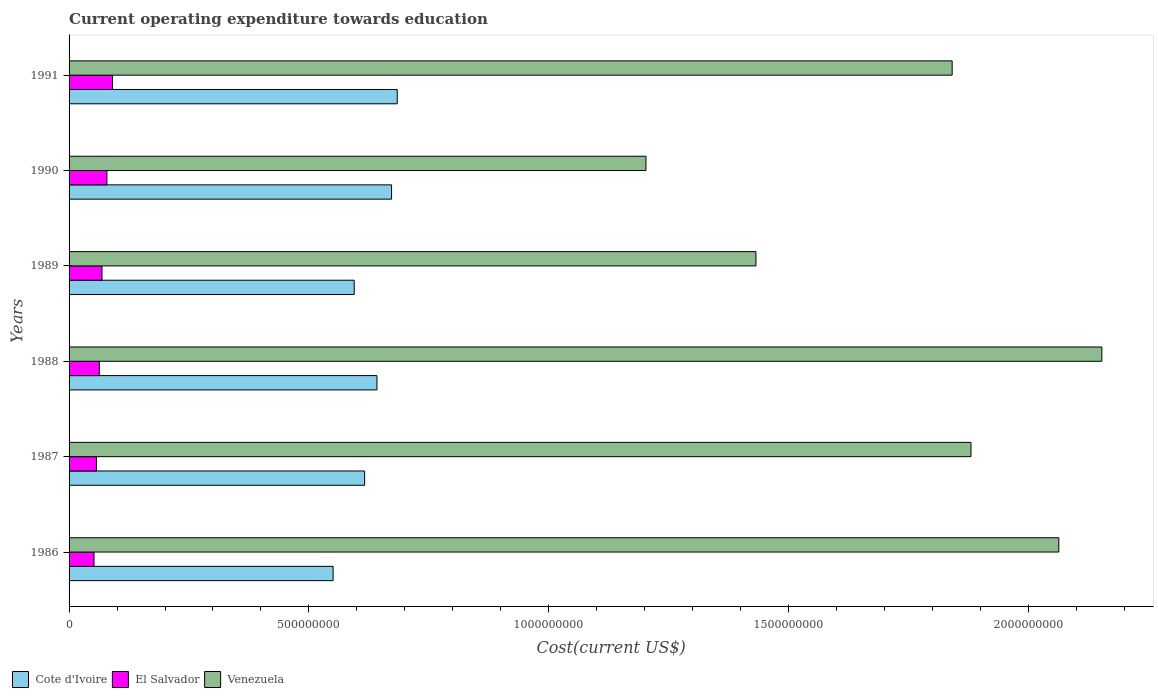Are the number of bars on each tick of the Y-axis equal?
Provide a succinct answer. Yes. What is the expenditure towards education in Venezuela in 1989?
Offer a terse response. 1.43e+09. Across all years, what is the maximum expenditure towards education in Venezuela?
Your answer should be very brief. 2.15e+09. Across all years, what is the minimum expenditure towards education in Venezuela?
Your answer should be very brief. 1.20e+09. In which year was the expenditure towards education in Venezuela minimum?
Offer a terse response. 1990. What is the total expenditure towards education in Venezuela in the graph?
Ensure brevity in your answer.  1.06e+1. What is the difference between the expenditure towards education in Venezuela in 1987 and that in 1988?
Your answer should be compact. -2.73e+08. What is the difference between the expenditure towards education in Cote d'Ivoire in 1988 and the expenditure towards education in El Salvador in 1989?
Your answer should be compact. 5.73e+08. What is the average expenditure towards education in Cote d'Ivoire per year?
Provide a short and direct response. 6.27e+08. In the year 1989, what is the difference between the expenditure towards education in Cote d'Ivoire and expenditure towards education in Venezuela?
Make the answer very short. -8.37e+08. What is the ratio of the expenditure towards education in El Salvador in 1990 to that in 1991?
Your answer should be compact. 0.87. Is the difference between the expenditure towards education in Cote d'Ivoire in 1986 and 1991 greater than the difference between the expenditure towards education in Venezuela in 1986 and 1991?
Your response must be concise. No. What is the difference between the highest and the second highest expenditure towards education in Cote d'Ivoire?
Offer a very short reply. 1.18e+07. What is the difference between the highest and the lowest expenditure towards education in Cote d'Ivoire?
Keep it short and to the point. 1.34e+08. Is the sum of the expenditure towards education in El Salvador in 1988 and 1990 greater than the maximum expenditure towards education in Cote d'Ivoire across all years?
Your response must be concise. No. What does the 1st bar from the top in 1987 represents?
Provide a short and direct response. Venezuela. What does the 2nd bar from the bottom in 1991 represents?
Your answer should be compact. El Salvador. What is the difference between two consecutive major ticks on the X-axis?
Your response must be concise. 5.00e+08. What is the title of the graph?
Provide a succinct answer. Current operating expenditure towards education. What is the label or title of the X-axis?
Make the answer very short. Cost(current US$). What is the Cost(current US$) of Cote d'Ivoire in 1986?
Make the answer very short. 5.50e+08. What is the Cost(current US$) in El Salvador in 1986?
Give a very brief answer. 5.20e+07. What is the Cost(current US$) in Venezuela in 1986?
Your response must be concise. 2.06e+09. What is the Cost(current US$) in Cote d'Ivoire in 1987?
Offer a terse response. 6.16e+08. What is the Cost(current US$) of El Salvador in 1987?
Keep it short and to the point. 5.70e+07. What is the Cost(current US$) in Venezuela in 1987?
Keep it short and to the point. 1.88e+09. What is the Cost(current US$) of Cote d'Ivoire in 1988?
Offer a very short reply. 6.42e+08. What is the Cost(current US$) of El Salvador in 1988?
Your answer should be compact. 6.31e+07. What is the Cost(current US$) of Venezuela in 1988?
Give a very brief answer. 2.15e+09. What is the Cost(current US$) of Cote d'Ivoire in 1989?
Your answer should be compact. 5.94e+08. What is the Cost(current US$) of El Salvador in 1989?
Your answer should be very brief. 6.86e+07. What is the Cost(current US$) in Venezuela in 1989?
Offer a very short reply. 1.43e+09. What is the Cost(current US$) of Cote d'Ivoire in 1990?
Your response must be concise. 6.72e+08. What is the Cost(current US$) of El Salvador in 1990?
Your answer should be compact. 7.89e+07. What is the Cost(current US$) of Venezuela in 1990?
Give a very brief answer. 1.20e+09. What is the Cost(current US$) in Cote d'Ivoire in 1991?
Ensure brevity in your answer.  6.84e+08. What is the Cost(current US$) of El Salvador in 1991?
Your response must be concise. 9.04e+07. What is the Cost(current US$) of Venezuela in 1991?
Your answer should be very brief. 1.84e+09. Across all years, what is the maximum Cost(current US$) in Cote d'Ivoire?
Make the answer very short. 6.84e+08. Across all years, what is the maximum Cost(current US$) of El Salvador?
Provide a succinct answer. 9.04e+07. Across all years, what is the maximum Cost(current US$) of Venezuela?
Give a very brief answer. 2.15e+09. Across all years, what is the minimum Cost(current US$) in Cote d'Ivoire?
Your answer should be compact. 5.50e+08. Across all years, what is the minimum Cost(current US$) of El Salvador?
Your answer should be very brief. 5.20e+07. Across all years, what is the minimum Cost(current US$) of Venezuela?
Your answer should be compact. 1.20e+09. What is the total Cost(current US$) of Cote d'Ivoire in the graph?
Offer a terse response. 3.76e+09. What is the total Cost(current US$) of El Salvador in the graph?
Keep it short and to the point. 4.10e+08. What is the total Cost(current US$) of Venezuela in the graph?
Offer a terse response. 1.06e+1. What is the difference between the Cost(current US$) of Cote d'Ivoire in 1986 and that in 1987?
Give a very brief answer. -6.57e+07. What is the difference between the Cost(current US$) in El Salvador in 1986 and that in 1987?
Give a very brief answer. -5.03e+06. What is the difference between the Cost(current US$) in Venezuela in 1986 and that in 1987?
Offer a terse response. 1.83e+08. What is the difference between the Cost(current US$) in Cote d'Ivoire in 1986 and that in 1988?
Your answer should be very brief. -9.14e+07. What is the difference between the Cost(current US$) in El Salvador in 1986 and that in 1988?
Your answer should be very brief. -1.11e+07. What is the difference between the Cost(current US$) of Venezuela in 1986 and that in 1988?
Offer a very short reply. -8.97e+07. What is the difference between the Cost(current US$) in Cote d'Ivoire in 1986 and that in 1989?
Offer a very short reply. -4.40e+07. What is the difference between the Cost(current US$) in El Salvador in 1986 and that in 1989?
Your answer should be very brief. -1.67e+07. What is the difference between the Cost(current US$) in Venezuela in 1986 and that in 1989?
Offer a terse response. 6.31e+08. What is the difference between the Cost(current US$) in Cote d'Ivoire in 1986 and that in 1990?
Provide a succinct answer. -1.22e+08. What is the difference between the Cost(current US$) of El Salvador in 1986 and that in 1990?
Provide a short and direct response. -2.69e+07. What is the difference between the Cost(current US$) of Venezuela in 1986 and that in 1990?
Provide a short and direct response. 8.61e+08. What is the difference between the Cost(current US$) of Cote d'Ivoire in 1986 and that in 1991?
Provide a succinct answer. -1.34e+08. What is the difference between the Cost(current US$) in El Salvador in 1986 and that in 1991?
Offer a very short reply. -3.85e+07. What is the difference between the Cost(current US$) in Venezuela in 1986 and that in 1991?
Your answer should be very brief. 2.22e+08. What is the difference between the Cost(current US$) of Cote d'Ivoire in 1987 and that in 1988?
Make the answer very short. -2.57e+07. What is the difference between the Cost(current US$) in El Salvador in 1987 and that in 1988?
Your answer should be very brief. -6.09e+06. What is the difference between the Cost(current US$) of Venezuela in 1987 and that in 1988?
Make the answer very short. -2.73e+08. What is the difference between the Cost(current US$) in Cote d'Ivoire in 1987 and that in 1989?
Ensure brevity in your answer.  2.17e+07. What is the difference between the Cost(current US$) in El Salvador in 1987 and that in 1989?
Make the answer very short. -1.16e+07. What is the difference between the Cost(current US$) in Venezuela in 1987 and that in 1989?
Your answer should be very brief. 4.48e+08. What is the difference between the Cost(current US$) in Cote d'Ivoire in 1987 and that in 1990?
Provide a succinct answer. -5.61e+07. What is the difference between the Cost(current US$) of El Salvador in 1987 and that in 1990?
Make the answer very short. -2.19e+07. What is the difference between the Cost(current US$) in Venezuela in 1987 and that in 1990?
Offer a terse response. 6.78e+08. What is the difference between the Cost(current US$) in Cote d'Ivoire in 1987 and that in 1991?
Offer a very short reply. -6.79e+07. What is the difference between the Cost(current US$) of El Salvador in 1987 and that in 1991?
Provide a short and direct response. -3.35e+07. What is the difference between the Cost(current US$) of Venezuela in 1987 and that in 1991?
Ensure brevity in your answer.  3.93e+07. What is the difference between the Cost(current US$) of Cote d'Ivoire in 1988 and that in 1989?
Give a very brief answer. 4.74e+07. What is the difference between the Cost(current US$) of El Salvador in 1988 and that in 1989?
Your response must be concise. -5.55e+06. What is the difference between the Cost(current US$) in Venezuela in 1988 and that in 1989?
Provide a succinct answer. 7.21e+08. What is the difference between the Cost(current US$) in Cote d'Ivoire in 1988 and that in 1990?
Provide a short and direct response. -3.04e+07. What is the difference between the Cost(current US$) in El Salvador in 1988 and that in 1990?
Offer a very short reply. -1.58e+07. What is the difference between the Cost(current US$) in Venezuela in 1988 and that in 1990?
Keep it short and to the point. 9.50e+08. What is the difference between the Cost(current US$) in Cote d'Ivoire in 1988 and that in 1991?
Provide a succinct answer. -4.22e+07. What is the difference between the Cost(current US$) of El Salvador in 1988 and that in 1991?
Your answer should be very brief. -2.74e+07. What is the difference between the Cost(current US$) of Venezuela in 1988 and that in 1991?
Your response must be concise. 3.12e+08. What is the difference between the Cost(current US$) of Cote d'Ivoire in 1989 and that in 1990?
Keep it short and to the point. -7.78e+07. What is the difference between the Cost(current US$) of El Salvador in 1989 and that in 1990?
Provide a short and direct response. -1.03e+07. What is the difference between the Cost(current US$) of Venezuela in 1989 and that in 1990?
Provide a succinct answer. 2.29e+08. What is the difference between the Cost(current US$) in Cote d'Ivoire in 1989 and that in 1991?
Your response must be concise. -8.97e+07. What is the difference between the Cost(current US$) of El Salvador in 1989 and that in 1991?
Your response must be concise. -2.18e+07. What is the difference between the Cost(current US$) in Venezuela in 1989 and that in 1991?
Offer a very short reply. -4.09e+08. What is the difference between the Cost(current US$) of Cote d'Ivoire in 1990 and that in 1991?
Make the answer very short. -1.18e+07. What is the difference between the Cost(current US$) in El Salvador in 1990 and that in 1991?
Provide a short and direct response. -1.16e+07. What is the difference between the Cost(current US$) in Venezuela in 1990 and that in 1991?
Give a very brief answer. -6.38e+08. What is the difference between the Cost(current US$) of Cote d'Ivoire in 1986 and the Cost(current US$) of El Salvador in 1987?
Offer a terse response. 4.93e+08. What is the difference between the Cost(current US$) of Cote d'Ivoire in 1986 and the Cost(current US$) of Venezuela in 1987?
Offer a terse response. -1.33e+09. What is the difference between the Cost(current US$) in El Salvador in 1986 and the Cost(current US$) in Venezuela in 1987?
Your answer should be compact. -1.83e+09. What is the difference between the Cost(current US$) in Cote d'Ivoire in 1986 and the Cost(current US$) in El Salvador in 1988?
Provide a short and direct response. 4.87e+08. What is the difference between the Cost(current US$) in Cote d'Ivoire in 1986 and the Cost(current US$) in Venezuela in 1988?
Provide a succinct answer. -1.60e+09. What is the difference between the Cost(current US$) of El Salvador in 1986 and the Cost(current US$) of Venezuela in 1988?
Ensure brevity in your answer.  -2.10e+09. What is the difference between the Cost(current US$) of Cote d'Ivoire in 1986 and the Cost(current US$) of El Salvador in 1989?
Give a very brief answer. 4.82e+08. What is the difference between the Cost(current US$) in Cote d'Ivoire in 1986 and the Cost(current US$) in Venezuela in 1989?
Your response must be concise. -8.81e+08. What is the difference between the Cost(current US$) of El Salvador in 1986 and the Cost(current US$) of Venezuela in 1989?
Your answer should be very brief. -1.38e+09. What is the difference between the Cost(current US$) of Cote d'Ivoire in 1986 and the Cost(current US$) of El Salvador in 1990?
Your answer should be compact. 4.72e+08. What is the difference between the Cost(current US$) in Cote d'Ivoire in 1986 and the Cost(current US$) in Venezuela in 1990?
Make the answer very short. -6.52e+08. What is the difference between the Cost(current US$) in El Salvador in 1986 and the Cost(current US$) in Venezuela in 1990?
Provide a short and direct response. -1.15e+09. What is the difference between the Cost(current US$) in Cote d'Ivoire in 1986 and the Cost(current US$) in El Salvador in 1991?
Offer a terse response. 4.60e+08. What is the difference between the Cost(current US$) in Cote d'Ivoire in 1986 and the Cost(current US$) in Venezuela in 1991?
Provide a short and direct response. -1.29e+09. What is the difference between the Cost(current US$) in El Salvador in 1986 and the Cost(current US$) in Venezuela in 1991?
Your answer should be compact. -1.79e+09. What is the difference between the Cost(current US$) in Cote d'Ivoire in 1987 and the Cost(current US$) in El Salvador in 1988?
Keep it short and to the point. 5.53e+08. What is the difference between the Cost(current US$) of Cote d'Ivoire in 1987 and the Cost(current US$) of Venezuela in 1988?
Make the answer very short. -1.54e+09. What is the difference between the Cost(current US$) in El Salvador in 1987 and the Cost(current US$) in Venezuela in 1988?
Give a very brief answer. -2.10e+09. What is the difference between the Cost(current US$) in Cote d'Ivoire in 1987 and the Cost(current US$) in El Salvador in 1989?
Offer a terse response. 5.48e+08. What is the difference between the Cost(current US$) in Cote d'Ivoire in 1987 and the Cost(current US$) in Venezuela in 1989?
Offer a very short reply. -8.16e+08. What is the difference between the Cost(current US$) in El Salvador in 1987 and the Cost(current US$) in Venezuela in 1989?
Offer a terse response. -1.37e+09. What is the difference between the Cost(current US$) of Cote d'Ivoire in 1987 and the Cost(current US$) of El Salvador in 1990?
Your response must be concise. 5.37e+08. What is the difference between the Cost(current US$) in Cote d'Ivoire in 1987 and the Cost(current US$) in Venezuela in 1990?
Your answer should be very brief. -5.86e+08. What is the difference between the Cost(current US$) in El Salvador in 1987 and the Cost(current US$) in Venezuela in 1990?
Offer a very short reply. -1.15e+09. What is the difference between the Cost(current US$) in Cote d'Ivoire in 1987 and the Cost(current US$) in El Salvador in 1991?
Your answer should be very brief. 5.26e+08. What is the difference between the Cost(current US$) in Cote d'Ivoire in 1987 and the Cost(current US$) in Venezuela in 1991?
Your answer should be compact. -1.22e+09. What is the difference between the Cost(current US$) in El Salvador in 1987 and the Cost(current US$) in Venezuela in 1991?
Offer a very short reply. -1.78e+09. What is the difference between the Cost(current US$) in Cote d'Ivoire in 1988 and the Cost(current US$) in El Salvador in 1989?
Provide a short and direct response. 5.73e+08. What is the difference between the Cost(current US$) of Cote d'Ivoire in 1988 and the Cost(current US$) of Venezuela in 1989?
Give a very brief answer. -7.90e+08. What is the difference between the Cost(current US$) of El Salvador in 1988 and the Cost(current US$) of Venezuela in 1989?
Your answer should be very brief. -1.37e+09. What is the difference between the Cost(current US$) in Cote d'Ivoire in 1988 and the Cost(current US$) in El Salvador in 1990?
Provide a succinct answer. 5.63e+08. What is the difference between the Cost(current US$) in Cote d'Ivoire in 1988 and the Cost(current US$) in Venezuela in 1990?
Your response must be concise. -5.61e+08. What is the difference between the Cost(current US$) in El Salvador in 1988 and the Cost(current US$) in Venezuela in 1990?
Offer a terse response. -1.14e+09. What is the difference between the Cost(current US$) in Cote d'Ivoire in 1988 and the Cost(current US$) in El Salvador in 1991?
Ensure brevity in your answer.  5.51e+08. What is the difference between the Cost(current US$) in Cote d'Ivoire in 1988 and the Cost(current US$) in Venezuela in 1991?
Give a very brief answer. -1.20e+09. What is the difference between the Cost(current US$) in El Salvador in 1988 and the Cost(current US$) in Venezuela in 1991?
Offer a very short reply. -1.78e+09. What is the difference between the Cost(current US$) of Cote d'Ivoire in 1989 and the Cost(current US$) of El Salvador in 1990?
Give a very brief answer. 5.16e+08. What is the difference between the Cost(current US$) of Cote d'Ivoire in 1989 and the Cost(current US$) of Venezuela in 1990?
Provide a short and direct response. -6.08e+08. What is the difference between the Cost(current US$) in El Salvador in 1989 and the Cost(current US$) in Venezuela in 1990?
Ensure brevity in your answer.  -1.13e+09. What is the difference between the Cost(current US$) of Cote d'Ivoire in 1989 and the Cost(current US$) of El Salvador in 1991?
Your response must be concise. 5.04e+08. What is the difference between the Cost(current US$) in Cote d'Ivoire in 1989 and the Cost(current US$) in Venezuela in 1991?
Provide a short and direct response. -1.25e+09. What is the difference between the Cost(current US$) of El Salvador in 1989 and the Cost(current US$) of Venezuela in 1991?
Ensure brevity in your answer.  -1.77e+09. What is the difference between the Cost(current US$) of Cote d'Ivoire in 1990 and the Cost(current US$) of El Salvador in 1991?
Ensure brevity in your answer.  5.82e+08. What is the difference between the Cost(current US$) in Cote d'Ivoire in 1990 and the Cost(current US$) in Venezuela in 1991?
Your answer should be compact. -1.17e+09. What is the difference between the Cost(current US$) of El Salvador in 1990 and the Cost(current US$) of Venezuela in 1991?
Offer a terse response. -1.76e+09. What is the average Cost(current US$) of Cote d'Ivoire per year?
Your answer should be compact. 6.27e+08. What is the average Cost(current US$) of El Salvador per year?
Your answer should be compact. 6.83e+07. What is the average Cost(current US$) in Venezuela per year?
Provide a succinct answer. 1.76e+09. In the year 1986, what is the difference between the Cost(current US$) of Cote d'Ivoire and Cost(current US$) of El Salvador?
Keep it short and to the point. 4.98e+08. In the year 1986, what is the difference between the Cost(current US$) of Cote d'Ivoire and Cost(current US$) of Venezuela?
Provide a succinct answer. -1.51e+09. In the year 1986, what is the difference between the Cost(current US$) of El Salvador and Cost(current US$) of Venezuela?
Provide a succinct answer. -2.01e+09. In the year 1987, what is the difference between the Cost(current US$) in Cote d'Ivoire and Cost(current US$) in El Salvador?
Ensure brevity in your answer.  5.59e+08. In the year 1987, what is the difference between the Cost(current US$) of Cote d'Ivoire and Cost(current US$) of Venezuela?
Make the answer very short. -1.26e+09. In the year 1987, what is the difference between the Cost(current US$) in El Salvador and Cost(current US$) in Venezuela?
Provide a succinct answer. -1.82e+09. In the year 1988, what is the difference between the Cost(current US$) of Cote d'Ivoire and Cost(current US$) of El Salvador?
Keep it short and to the point. 5.79e+08. In the year 1988, what is the difference between the Cost(current US$) in Cote d'Ivoire and Cost(current US$) in Venezuela?
Offer a terse response. -1.51e+09. In the year 1988, what is the difference between the Cost(current US$) of El Salvador and Cost(current US$) of Venezuela?
Offer a terse response. -2.09e+09. In the year 1989, what is the difference between the Cost(current US$) in Cote d'Ivoire and Cost(current US$) in El Salvador?
Offer a very short reply. 5.26e+08. In the year 1989, what is the difference between the Cost(current US$) in Cote d'Ivoire and Cost(current US$) in Venezuela?
Give a very brief answer. -8.37e+08. In the year 1989, what is the difference between the Cost(current US$) of El Salvador and Cost(current US$) of Venezuela?
Provide a short and direct response. -1.36e+09. In the year 1990, what is the difference between the Cost(current US$) of Cote d'Ivoire and Cost(current US$) of El Salvador?
Ensure brevity in your answer.  5.93e+08. In the year 1990, what is the difference between the Cost(current US$) of Cote d'Ivoire and Cost(current US$) of Venezuela?
Your response must be concise. -5.30e+08. In the year 1990, what is the difference between the Cost(current US$) in El Salvador and Cost(current US$) in Venezuela?
Provide a succinct answer. -1.12e+09. In the year 1991, what is the difference between the Cost(current US$) of Cote d'Ivoire and Cost(current US$) of El Salvador?
Ensure brevity in your answer.  5.94e+08. In the year 1991, what is the difference between the Cost(current US$) of Cote d'Ivoire and Cost(current US$) of Venezuela?
Give a very brief answer. -1.16e+09. In the year 1991, what is the difference between the Cost(current US$) of El Salvador and Cost(current US$) of Venezuela?
Your answer should be very brief. -1.75e+09. What is the ratio of the Cost(current US$) in Cote d'Ivoire in 1986 to that in 1987?
Your answer should be compact. 0.89. What is the ratio of the Cost(current US$) in El Salvador in 1986 to that in 1987?
Your answer should be compact. 0.91. What is the ratio of the Cost(current US$) of Venezuela in 1986 to that in 1987?
Offer a very short reply. 1.1. What is the ratio of the Cost(current US$) of Cote d'Ivoire in 1986 to that in 1988?
Provide a short and direct response. 0.86. What is the ratio of the Cost(current US$) of El Salvador in 1986 to that in 1988?
Provide a succinct answer. 0.82. What is the ratio of the Cost(current US$) of Venezuela in 1986 to that in 1988?
Your response must be concise. 0.96. What is the ratio of the Cost(current US$) in Cote d'Ivoire in 1986 to that in 1989?
Your answer should be very brief. 0.93. What is the ratio of the Cost(current US$) in El Salvador in 1986 to that in 1989?
Ensure brevity in your answer.  0.76. What is the ratio of the Cost(current US$) in Venezuela in 1986 to that in 1989?
Make the answer very short. 1.44. What is the ratio of the Cost(current US$) in Cote d'Ivoire in 1986 to that in 1990?
Provide a short and direct response. 0.82. What is the ratio of the Cost(current US$) in El Salvador in 1986 to that in 1990?
Give a very brief answer. 0.66. What is the ratio of the Cost(current US$) of Venezuela in 1986 to that in 1990?
Offer a terse response. 1.72. What is the ratio of the Cost(current US$) of Cote d'Ivoire in 1986 to that in 1991?
Your answer should be compact. 0.8. What is the ratio of the Cost(current US$) in El Salvador in 1986 to that in 1991?
Give a very brief answer. 0.57. What is the ratio of the Cost(current US$) in Venezuela in 1986 to that in 1991?
Make the answer very short. 1.12. What is the ratio of the Cost(current US$) in El Salvador in 1987 to that in 1988?
Your answer should be compact. 0.9. What is the ratio of the Cost(current US$) in Venezuela in 1987 to that in 1988?
Your answer should be very brief. 0.87. What is the ratio of the Cost(current US$) in Cote d'Ivoire in 1987 to that in 1989?
Offer a terse response. 1.04. What is the ratio of the Cost(current US$) in El Salvador in 1987 to that in 1989?
Ensure brevity in your answer.  0.83. What is the ratio of the Cost(current US$) in Venezuela in 1987 to that in 1989?
Provide a succinct answer. 1.31. What is the ratio of the Cost(current US$) of Cote d'Ivoire in 1987 to that in 1990?
Offer a terse response. 0.92. What is the ratio of the Cost(current US$) of El Salvador in 1987 to that in 1990?
Your response must be concise. 0.72. What is the ratio of the Cost(current US$) in Venezuela in 1987 to that in 1990?
Ensure brevity in your answer.  1.56. What is the ratio of the Cost(current US$) in Cote d'Ivoire in 1987 to that in 1991?
Make the answer very short. 0.9. What is the ratio of the Cost(current US$) in El Salvador in 1987 to that in 1991?
Ensure brevity in your answer.  0.63. What is the ratio of the Cost(current US$) in Venezuela in 1987 to that in 1991?
Give a very brief answer. 1.02. What is the ratio of the Cost(current US$) in Cote d'Ivoire in 1988 to that in 1989?
Provide a short and direct response. 1.08. What is the ratio of the Cost(current US$) of El Salvador in 1988 to that in 1989?
Ensure brevity in your answer.  0.92. What is the ratio of the Cost(current US$) of Venezuela in 1988 to that in 1989?
Your answer should be compact. 1.5. What is the ratio of the Cost(current US$) in Cote d'Ivoire in 1988 to that in 1990?
Your answer should be very brief. 0.95. What is the ratio of the Cost(current US$) in El Salvador in 1988 to that in 1990?
Your answer should be very brief. 0.8. What is the ratio of the Cost(current US$) of Venezuela in 1988 to that in 1990?
Provide a succinct answer. 1.79. What is the ratio of the Cost(current US$) in Cote d'Ivoire in 1988 to that in 1991?
Make the answer very short. 0.94. What is the ratio of the Cost(current US$) of El Salvador in 1988 to that in 1991?
Your response must be concise. 0.7. What is the ratio of the Cost(current US$) of Venezuela in 1988 to that in 1991?
Your response must be concise. 1.17. What is the ratio of the Cost(current US$) of Cote d'Ivoire in 1989 to that in 1990?
Your response must be concise. 0.88. What is the ratio of the Cost(current US$) of El Salvador in 1989 to that in 1990?
Your response must be concise. 0.87. What is the ratio of the Cost(current US$) of Venezuela in 1989 to that in 1990?
Make the answer very short. 1.19. What is the ratio of the Cost(current US$) in Cote d'Ivoire in 1989 to that in 1991?
Provide a short and direct response. 0.87. What is the ratio of the Cost(current US$) in El Salvador in 1989 to that in 1991?
Ensure brevity in your answer.  0.76. What is the ratio of the Cost(current US$) of Cote d'Ivoire in 1990 to that in 1991?
Offer a terse response. 0.98. What is the ratio of the Cost(current US$) in El Salvador in 1990 to that in 1991?
Your answer should be compact. 0.87. What is the ratio of the Cost(current US$) of Venezuela in 1990 to that in 1991?
Ensure brevity in your answer.  0.65. What is the difference between the highest and the second highest Cost(current US$) in Cote d'Ivoire?
Give a very brief answer. 1.18e+07. What is the difference between the highest and the second highest Cost(current US$) of El Salvador?
Your answer should be compact. 1.16e+07. What is the difference between the highest and the second highest Cost(current US$) in Venezuela?
Your answer should be very brief. 8.97e+07. What is the difference between the highest and the lowest Cost(current US$) in Cote d'Ivoire?
Make the answer very short. 1.34e+08. What is the difference between the highest and the lowest Cost(current US$) in El Salvador?
Offer a very short reply. 3.85e+07. What is the difference between the highest and the lowest Cost(current US$) in Venezuela?
Offer a terse response. 9.50e+08. 